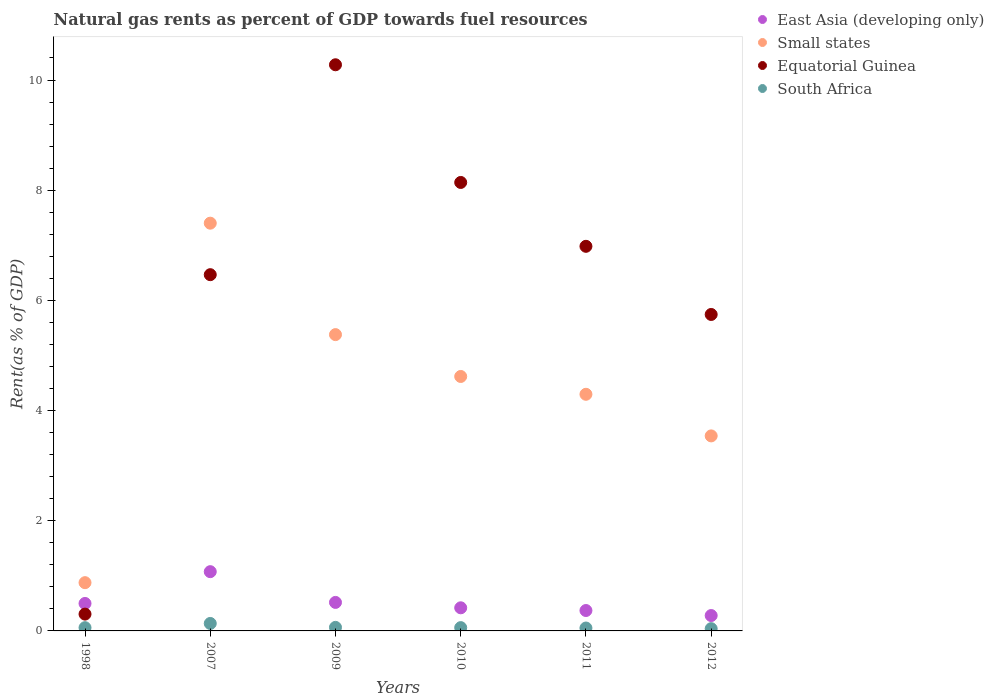Is the number of dotlines equal to the number of legend labels?
Ensure brevity in your answer.  Yes. What is the matural gas rent in Small states in 2012?
Give a very brief answer. 3.54. Across all years, what is the maximum matural gas rent in South Africa?
Give a very brief answer. 0.14. Across all years, what is the minimum matural gas rent in East Asia (developing only)?
Offer a terse response. 0.28. In which year was the matural gas rent in Equatorial Guinea maximum?
Your answer should be very brief. 2009. What is the total matural gas rent in Small states in the graph?
Provide a short and direct response. 26.11. What is the difference between the matural gas rent in Equatorial Guinea in 2009 and that in 2012?
Your answer should be very brief. 4.53. What is the difference between the matural gas rent in East Asia (developing only) in 2010 and the matural gas rent in South Africa in 2012?
Offer a very short reply. 0.38. What is the average matural gas rent in Small states per year?
Your answer should be compact. 4.35. In the year 2011, what is the difference between the matural gas rent in Small states and matural gas rent in East Asia (developing only)?
Make the answer very short. 3.93. What is the ratio of the matural gas rent in East Asia (developing only) in 2011 to that in 2012?
Keep it short and to the point. 1.33. Is the difference between the matural gas rent in Small states in 2010 and 2011 greater than the difference between the matural gas rent in East Asia (developing only) in 2010 and 2011?
Your answer should be compact. Yes. What is the difference between the highest and the second highest matural gas rent in South Africa?
Give a very brief answer. 0.07. What is the difference between the highest and the lowest matural gas rent in East Asia (developing only)?
Give a very brief answer. 0.8. In how many years, is the matural gas rent in South Africa greater than the average matural gas rent in South Africa taken over all years?
Offer a very short reply. 1. Is it the case that in every year, the sum of the matural gas rent in South Africa and matural gas rent in Small states  is greater than the sum of matural gas rent in East Asia (developing only) and matural gas rent in Equatorial Guinea?
Keep it short and to the point. Yes. Is it the case that in every year, the sum of the matural gas rent in South Africa and matural gas rent in East Asia (developing only)  is greater than the matural gas rent in Small states?
Provide a short and direct response. No. Is the matural gas rent in South Africa strictly greater than the matural gas rent in East Asia (developing only) over the years?
Your response must be concise. No. Is the matural gas rent in East Asia (developing only) strictly less than the matural gas rent in Equatorial Guinea over the years?
Your answer should be very brief. No. How many years are there in the graph?
Give a very brief answer. 6. What is the difference between two consecutive major ticks on the Y-axis?
Ensure brevity in your answer.  2. Are the values on the major ticks of Y-axis written in scientific E-notation?
Make the answer very short. No. Does the graph contain any zero values?
Your response must be concise. No. How many legend labels are there?
Offer a very short reply. 4. How are the legend labels stacked?
Your answer should be very brief. Vertical. What is the title of the graph?
Your answer should be very brief. Natural gas rents as percent of GDP towards fuel resources. Does "Pakistan" appear as one of the legend labels in the graph?
Keep it short and to the point. No. What is the label or title of the X-axis?
Give a very brief answer. Years. What is the label or title of the Y-axis?
Provide a short and direct response. Rent(as % of GDP). What is the Rent(as % of GDP) in East Asia (developing only) in 1998?
Keep it short and to the point. 0.5. What is the Rent(as % of GDP) of Small states in 1998?
Keep it short and to the point. 0.88. What is the Rent(as % of GDP) of Equatorial Guinea in 1998?
Provide a short and direct response. 0.31. What is the Rent(as % of GDP) of South Africa in 1998?
Offer a terse response. 0.06. What is the Rent(as % of GDP) of East Asia (developing only) in 2007?
Ensure brevity in your answer.  1.08. What is the Rent(as % of GDP) of Small states in 2007?
Keep it short and to the point. 7.4. What is the Rent(as % of GDP) in Equatorial Guinea in 2007?
Your answer should be very brief. 6.47. What is the Rent(as % of GDP) in South Africa in 2007?
Give a very brief answer. 0.14. What is the Rent(as % of GDP) of East Asia (developing only) in 2009?
Your answer should be compact. 0.52. What is the Rent(as % of GDP) of Small states in 2009?
Your answer should be very brief. 5.38. What is the Rent(as % of GDP) in Equatorial Guinea in 2009?
Provide a succinct answer. 10.28. What is the Rent(as % of GDP) in South Africa in 2009?
Offer a very short reply. 0.06. What is the Rent(as % of GDP) of East Asia (developing only) in 2010?
Make the answer very short. 0.42. What is the Rent(as % of GDP) in Small states in 2010?
Give a very brief answer. 4.62. What is the Rent(as % of GDP) of Equatorial Guinea in 2010?
Make the answer very short. 8.14. What is the Rent(as % of GDP) in South Africa in 2010?
Your answer should be compact. 0.06. What is the Rent(as % of GDP) of East Asia (developing only) in 2011?
Provide a succinct answer. 0.37. What is the Rent(as % of GDP) in Small states in 2011?
Offer a terse response. 4.3. What is the Rent(as % of GDP) in Equatorial Guinea in 2011?
Your answer should be compact. 6.98. What is the Rent(as % of GDP) of South Africa in 2011?
Offer a terse response. 0.05. What is the Rent(as % of GDP) in East Asia (developing only) in 2012?
Give a very brief answer. 0.28. What is the Rent(as % of GDP) in Small states in 2012?
Offer a terse response. 3.54. What is the Rent(as % of GDP) in Equatorial Guinea in 2012?
Your answer should be very brief. 5.74. What is the Rent(as % of GDP) in South Africa in 2012?
Keep it short and to the point. 0.04. Across all years, what is the maximum Rent(as % of GDP) of East Asia (developing only)?
Your answer should be very brief. 1.08. Across all years, what is the maximum Rent(as % of GDP) of Small states?
Ensure brevity in your answer.  7.4. Across all years, what is the maximum Rent(as % of GDP) of Equatorial Guinea?
Provide a short and direct response. 10.28. Across all years, what is the maximum Rent(as % of GDP) in South Africa?
Provide a succinct answer. 0.14. Across all years, what is the minimum Rent(as % of GDP) of East Asia (developing only)?
Offer a terse response. 0.28. Across all years, what is the minimum Rent(as % of GDP) of Small states?
Provide a short and direct response. 0.88. Across all years, what is the minimum Rent(as % of GDP) of Equatorial Guinea?
Offer a terse response. 0.31. Across all years, what is the minimum Rent(as % of GDP) in South Africa?
Provide a succinct answer. 0.04. What is the total Rent(as % of GDP) in East Asia (developing only) in the graph?
Make the answer very short. 3.16. What is the total Rent(as % of GDP) of Small states in the graph?
Keep it short and to the point. 26.11. What is the total Rent(as % of GDP) in Equatorial Guinea in the graph?
Give a very brief answer. 37.92. What is the total Rent(as % of GDP) of South Africa in the graph?
Your answer should be very brief. 0.41. What is the difference between the Rent(as % of GDP) in East Asia (developing only) in 1998 and that in 2007?
Provide a short and direct response. -0.58. What is the difference between the Rent(as % of GDP) in Small states in 1998 and that in 2007?
Offer a terse response. -6.53. What is the difference between the Rent(as % of GDP) in Equatorial Guinea in 1998 and that in 2007?
Give a very brief answer. -6.16. What is the difference between the Rent(as % of GDP) in South Africa in 1998 and that in 2007?
Offer a very short reply. -0.08. What is the difference between the Rent(as % of GDP) of East Asia (developing only) in 1998 and that in 2009?
Make the answer very short. -0.02. What is the difference between the Rent(as % of GDP) of Small states in 1998 and that in 2009?
Your answer should be compact. -4.5. What is the difference between the Rent(as % of GDP) of Equatorial Guinea in 1998 and that in 2009?
Make the answer very short. -9.97. What is the difference between the Rent(as % of GDP) in South Africa in 1998 and that in 2009?
Keep it short and to the point. -0.01. What is the difference between the Rent(as % of GDP) of East Asia (developing only) in 1998 and that in 2010?
Offer a terse response. 0.08. What is the difference between the Rent(as % of GDP) in Small states in 1998 and that in 2010?
Provide a succinct answer. -3.74. What is the difference between the Rent(as % of GDP) of Equatorial Guinea in 1998 and that in 2010?
Your response must be concise. -7.84. What is the difference between the Rent(as % of GDP) in South Africa in 1998 and that in 2010?
Ensure brevity in your answer.  -0. What is the difference between the Rent(as % of GDP) of East Asia (developing only) in 1998 and that in 2011?
Keep it short and to the point. 0.13. What is the difference between the Rent(as % of GDP) of Small states in 1998 and that in 2011?
Ensure brevity in your answer.  -3.42. What is the difference between the Rent(as % of GDP) in Equatorial Guinea in 1998 and that in 2011?
Ensure brevity in your answer.  -6.68. What is the difference between the Rent(as % of GDP) of South Africa in 1998 and that in 2011?
Your answer should be compact. 0.01. What is the difference between the Rent(as % of GDP) of East Asia (developing only) in 1998 and that in 2012?
Provide a short and direct response. 0.22. What is the difference between the Rent(as % of GDP) of Small states in 1998 and that in 2012?
Your answer should be compact. -2.66. What is the difference between the Rent(as % of GDP) of Equatorial Guinea in 1998 and that in 2012?
Provide a succinct answer. -5.44. What is the difference between the Rent(as % of GDP) in South Africa in 1998 and that in 2012?
Ensure brevity in your answer.  0.02. What is the difference between the Rent(as % of GDP) in East Asia (developing only) in 2007 and that in 2009?
Provide a short and direct response. 0.56. What is the difference between the Rent(as % of GDP) in Small states in 2007 and that in 2009?
Your answer should be compact. 2.02. What is the difference between the Rent(as % of GDP) of Equatorial Guinea in 2007 and that in 2009?
Give a very brief answer. -3.81. What is the difference between the Rent(as % of GDP) in South Africa in 2007 and that in 2009?
Give a very brief answer. 0.07. What is the difference between the Rent(as % of GDP) of East Asia (developing only) in 2007 and that in 2010?
Offer a terse response. 0.66. What is the difference between the Rent(as % of GDP) of Small states in 2007 and that in 2010?
Make the answer very short. 2.78. What is the difference between the Rent(as % of GDP) in Equatorial Guinea in 2007 and that in 2010?
Offer a terse response. -1.67. What is the difference between the Rent(as % of GDP) in South Africa in 2007 and that in 2010?
Provide a short and direct response. 0.08. What is the difference between the Rent(as % of GDP) of East Asia (developing only) in 2007 and that in 2011?
Your answer should be very brief. 0.71. What is the difference between the Rent(as % of GDP) in Small states in 2007 and that in 2011?
Offer a terse response. 3.11. What is the difference between the Rent(as % of GDP) of Equatorial Guinea in 2007 and that in 2011?
Give a very brief answer. -0.51. What is the difference between the Rent(as % of GDP) in South Africa in 2007 and that in 2011?
Your answer should be very brief. 0.08. What is the difference between the Rent(as % of GDP) of East Asia (developing only) in 2007 and that in 2012?
Provide a succinct answer. 0.8. What is the difference between the Rent(as % of GDP) of Small states in 2007 and that in 2012?
Your answer should be very brief. 3.86. What is the difference between the Rent(as % of GDP) of Equatorial Guinea in 2007 and that in 2012?
Your answer should be compact. 0.72. What is the difference between the Rent(as % of GDP) of South Africa in 2007 and that in 2012?
Offer a very short reply. 0.09. What is the difference between the Rent(as % of GDP) in East Asia (developing only) in 2009 and that in 2010?
Make the answer very short. 0.1. What is the difference between the Rent(as % of GDP) in Small states in 2009 and that in 2010?
Your response must be concise. 0.76. What is the difference between the Rent(as % of GDP) of Equatorial Guinea in 2009 and that in 2010?
Keep it short and to the point. 2.14. What is the difference between the Rent(as % of GDP) in South Africa in 2009 and that in 2010?
Give a very brief answer. 0. What is the difference between the Rent(as % of GDP) in East Asia (developing only) in 2009 and that in 2011?
Provide a succinct answer. 0.15. What is the difference between the Rent(as % of GDP) in Small states in 2009 and that in 2011?
Make the answer very short. 1.08. What is the difference between the Rent(as % of GDP) of Equatorial Guinea in 2009 and that in 2011?
Offer a very short reply. 3.3. What is the difference between the Rent(as % of GDP) in South Africa in 2009 and that in 2011?
Offer a terse response. 0.01. What is the difference between the Rent(as % of GDP) of East Asia (developing only) in 2009 and that in 2012?
Provide a short and direct response. 0.24. What is the difference between the Rent(as % of GDP) of Small states in 2009 and that in 2012?
Your answer should be very brief. 1.84. What is the difference between the Rent(as % of GDP) in Equatorial Guinea in 2009 and that in 2012?
Give a very brief answer. 4.53. What is the difference between the Rent(as % of GDP) in South Africa in 2009 and that in 2012?
Ensure brevity in your answer.  0.02. What is the difference between the Rent(as % of GDP) of East Asia (developing only) in 2010 and that in 2011?
Provide a succinct answer. 0.05. What is the difference between the Rent(as % of GDP) of Small states in 2010 and that in 2011?
Ensure brevity in your answer.  0.32. What is the difference between the Rent(as % of GDP) in Equatorial Guinea in 2010 and that in 2011?
Your response must be concise. 1.16. What is the difference between the Rent(as % of GDP) of South Africa in 2010 and that in 2011?
Provide a short and direct response. 0.01. What is the difference between the Rent(as % of GDP) of East Asia (developing only) in 2010 and that in 2012?
Provide a short and direct response. 0.14. What is the difference between the Rent(as % of GDP) in Small states in 2010 and that in 2012?
Give a very brief answer. 1.08. What is the difference between the Rent(as % of GDP) in Equatorial Guinea in 2010 and that in 2012?
Your response must be concise. 2.4. What is the difference between the Rent(as % of GDP) of South Africa in 2010 and that in 2012?
Ensure brevity in your answer.  0.02. What is the difference between the Rent(as % of GDP) in East Asia (developing only) in 2011 and that in 2012?
Your answer should be compact. 0.09. What is the difference between the Rent(as % of GDP) of Small states in 2011 and that in 2012?
Ensure brevity in your answer.  0.76. What is the difference between the Rent(as % of GDP) of Equatorial Guinea in 2011 and that in 2012?
Your answer should be compact. 1.24. What is the difference between the Rent(as % of GDP) in South Africa in 2011 and that in 2012?
Offer a terse response. 0.01. What is the difference between the Rent(as % of GDP) in East Asia (developing only) in 1998 and the Rent(as % of GDP) in Small states in 2007?
Your answer should be very brief. -6.9. What is the difference between the Rent(as % of GDP) in East Asia (developing only) in 1998 and the Rent(as % of GDP) in Equatorial Guinea in 2007?
Your response must be concise. -5.97. What is the difference between the Rent(as % of GDP) of East Asia (developing only) in 1998 and the Rent(as % of GDP) of South Africa in 2007?
Your answer should be very brief. 0.36. What is the difference between the Rent(as % of GDP) of Small states in 1998 and the Rent(as % of GDP) of Equatorial Guinea in 2007?
Offer a very short reply. -5.59. What is the difference between the Rent(as % of GDP) of Small states in 1998 and the Rent(as % of GDP) of South Africa in 2007?
Ensure brevity in your answer.  0.74. What is the difference between the Rent(as % of GDP) of Equatorial Guinea in 1998 and the Rent(as % of GDP) of South Africa in 2007?
Keep it short and to the point. 0.17. What is the difference between the Rent(as % of GDP) of East Asia (developing only) in 1998 and the Rent(as % of GDP) of Small states in 2009?
Offer a very short reply. -4.88. What is the difference between the Rent(as % of GDP) in East Asia (developing only) in 1998 and the Rent(as % of GDP) in Equatorial Guinea in 2009?
Provide a succinct answer. -9.78. What is the difference between the Rent(as % of GDP) in East Asia (developing only) in 1998 and the Rent(as % of GDP) in South Africa in 2009?
Keep it short and to the point. 0.43. What is the difference between the Rent(as % of GDP) of Small states in 1998 and the Rent(as % of GDP) of Equatorial Guinea in 2009?
Your response must be concise. -9.4. What is the difference between the Rent(as % of GDP) in Small states in 1998 and the Rent(as % of GDP) in South Africa in 2009?
Give a very brief answer. 0.81. What is the difference between the Rent(as % of GDP) of Equatorial Guinea in 1998 and the Rent(as % of GDP) of South Africa in 2009?
Make the answer very short. 0.24. What is the difference between the Rent(as % of GDP) of East Asia (developing only) in 1998 and the Rent(as % of GDP) of Small states in 2010?
Your response must be concise. -4.12. What is the difference between the Rent(as % of GDP) of East Asia (developing only) in 1998 and the Rent(as % of GDP) of Equatorial Guinea in 2010?
Your answer should be compact. -7.64. What is the difference between the Rent(as % of GDP) in East Asia (developing only) in 1998 and the Rent(as % of GDP) in South Africa in 2010?
Your answer should be compact. 0.44. What is the difference between the Rent(as % of GDP) in Small states in 1998 and the Rent(as % of GDP) in Equatorial Guinea in 2010?
Keep it short and to the point. -7.26. What is the difference between the Rent(as % of GDP) of Small states in 1998 and the Rent(as % of GDP) of South Africa in 2010?
Your response must be concise. 0.82. What is the difference between the Rent(as % of GDP) of Equatorial Guinea in 1998 and the Rent(as % of GDP) of South Africa in 2010?
Your answer should be compact. 0.25. What is the difference between the Rent(as % of GDP) of East Asia (developing only) in 1998 and the Rent(as % of GDP) of Small states in 2011?
Provide a short and direct response. -3.8. What is the difference between the Rent(as % of GDP) in East Asia (developing only) in 1998 and the Rent(as % of GDP) in Equatorial Guinea in 2011?
Make the answer very short. -6.48. What is the difference between the Rent(as % of GDP) of East Asia (developing only) in 1998 and the Rent(as % of GDP) of South Africa in 2011?
Give a very brief answer. 0.45. What is the difference between the Rent(as % of GDP) of Small states in 1998 and the Rent(as % of GDP) of Equatorial Guinea in 2011?
Offer a terse response. -6.11. What is the difference between the Rent(as % of GDP) of Small states in 1998 and the Rent(as % of GDP) of South Africa in 2011?
Provide a succinct answer. 0.82. What is the difference between the Rent(as % of GDP) of Equatorial Guinea in 1998 and the Rent(as % of GDP) of South Africa in 2011?
Your answer should be very brief. 0.25. What is the difference between the Rent(as % of GDP) in East Asia (developing only) in 1998 and the Rent(as % of GDP) in Small states in 2012?
Ensure brevity in your answer.  -3.04. What is the difference between the Rent(as % of GDP) of East Asia (developing only) in 1998 and the Rent(as % of GDP) of Equatorial Guinea in 2012?
Give a very brief answer. -5.25. What is the difference between the Rent(as % of GDP) in East Asia (developing only) in 1998 and the Rent(as % of GDP) in South Africa in 2012?
Your response must be concise. 0.46. What is the difference between the Rent(as % of GDP) in Small states in 1998 and the Rent(as % of GDP) in Equatorial Guinea in 2012?
Give a very brief answer. -4.87. What is the difference between the Rent(as % of GDP) in Small states in 1998 and the Rent(as % of GDP) in South Africa in 2012?
Provide a succinct answer. 0.84. What is the difference between the Rent(as % of GDP) in Equatorial Guinea in 1998 and the Rent(as % of GDP) in South Africa in 2012?
Ensure brevity in your answer.  0.26. What is the difference between the Rent(as % of GDP) in East Asia (developing only) in 2007 and the Rent(as % of GDP) in Small states in 2009?
Offer a very short reply. -4.3. What is the difference between the Rent(as % of GDP) of East Asia (developing only) in 2007 and the Rent(as % of GDP) of Equatorial Guinea in 2009?
Provide a succinct answer. -9.2. What is the difference between the Rent(as % of GDP) in East Asia (developing only) in 2007 and the Rent(as % of GDP) in South Africa in 2009?
Provide a short and direct response. 1.01. What is the difference between the Rent(as % of GDP) in Small states in 2007 and the Rent(as % of GDP) in Equatorial Guinea in 2009?
Your response must be concise. -2.88. What is the difference between the Rent(as % of GDP) of Small states in 2007 and the Rent(as % of GDP) of South Africa in 2009?
Your answer should be very brief. 7.34. What is the difference between the Rent(as % of GDP) in Equatorial Guinea in 2007 and the Rent(as % of GDP) in South Africa in 2009?
Make the answer very short. 6.4. What is the difference between the Rent(as % of GDP) of East Asia (developing only) in 2007 and the Rent(as % of GDP) of Small states in 2010?
Give a very brief answer. -3.54. What is the difference between the Rent(as % of GDP) in East Asia (developing only) in 2007 and the Rent(as % of GDP) in Equatorial Guinea in 2010?
Offer a very short reply. -7.07. What is the difference between the Rent(as % of GDP) in East Asia (developing only) in 2007 and the Rent(as % of GDP) in South Africa in 2010?
Ensure brevity in your answer.  1.02. What is the difference between the Rent(as % of GDP) of Small states in 2007 and the Rent(as % of GDP) of Equatorial Guinea in 2010?
Keep it short and to the point. -0.74. What is the difference between the Rent(as % of GDP) of Small states in 2007 and the Rent(as % of GDP) of South Africa in 2010?
Keep it short and to the point. 7.34. What is the difference between the Rent(as % of GDP) in Equatorial Guinea in 2007 and the Rent(as % of GDP) in South Africa in 2010?
Give a very brief answer. 6.41. What is the difference between the Rent(as % of GDP) in East Asia (developing only) in 2007 and the Rent(as % of GDP) in Small states in 2011?
Provide a short and direct response. -3.22. What is the difference between the Rent(as % of GDP) of East Asia (developing only) in 2007 and the Rent(as % of GDP) of Equatorial Guinea in 2011?
Offer a very short reply. -5.91. What is the difference between the Rent(as % of GDP) in East Asia (developing only) in 2007 and the Rent(as % of GDP) in South Africa in 2011?
Offer a very short reply. 1.02. What is the difference between the Rent(as % of GDP) in Small states in 2007 and the Rent(as % of GDP) in Equatorial Guinea in 2011?
Your response must be concise. 0.42. What is the difference between the Rent(as % of GDP) of Small states in 2007 and the Rent(as % of GDP) of South Africa in 2011?
Your answer should be compact. 7.35. What is the difference between the Rent(as % of GDP) of Equatorial Guinea in 2007 and the Rent(as % of GDP) of South Africa in 2011?
Provide a succinct answer. 6.41. What is the difference between the Rent(as % of GDP) of East Asia (developing only) in 2007 and the Rent(as % of GDP) of Small states in 2012?
Keep it short and to the point. -2.46. What is the difference between the Rent(as % of GDP) of East Asia (developing only) in 2007 and the Rent(as % of GDP) of Equatorial Guinea in 2012?
Offer a terse response. -4.67. What is the difference between the Rent(as % of GDP) of East Asia (developing only) in 2007 and the Rent(as % of GDP) of South Africa in 2012?
Provide a short and direct response. 1.03. What is the difference between the Rent(as % of GDP) in Small states in 2007 and the Rent(as % of GDP) in Equatorial Guinea in 2012?
Provide a succinct answer. 1.66. What is the difference between the Rent(as % of GDP) in Small states in 2007 and the Rent(as % of GDP) in South Africa in 2012?
Give a very brief answer. 7.36. What is the difference between the Rent(as % of GDP) of Equatorial Guinea in 2007 and the Rent(as % of GDP) of South Africa in 2012?
Your response must be concise. 6.43. What is the difference between the Rent(as % of GDP) in East Asia (developing only) in 2009 and the Rent(as % of GDP) in Small states in 2010?
Your answer should be very brief. -4.1. What is the difference between the Rent(as % of GDP) in East Asia (developing only) in 2009 and the Rent(as % of GDP) in Equatorial Guinea in 2010?
Make the answer very short. -7.62. What is the difference between the Rent(as % of GDP) of East Asia (developing only) in 2009 and the Rent(as % of GDP) of South Africa in 2010?
Give a very brief answer. 0.46. What is the difference between the Rent(as % of GDP) of Small states in 2009 and the Rent(as % of GDP) of Equatorial Guinea in 2010?
Give a very brief answer. -2.76. What is the difference between the Rent(as % of GDP) of Small states in 2009 and the Rent(as % of GDP) of South Africa in 2010?
Your response must be concise. 5.32. What is the difference between the Rent(as % of GDP) of Equatorial Guinea in 2009 and the Rent(as % of GDP) of South Africa in 2010?
Offer a very short reply. 10.22. What is the difference between the Rent(as % of GDP) in East Asia (developing only) in 2009 and the Rent(as % of GDP) in Small states in 2011?
Ensure brevity in your answer.  -3.78. What is the difference between the Rent(as % of GDP) of East Asia (developing only) in 2009 and the Rent(as % of GDP) of Equatorial Guinea in 2011?
Your response must be concise. -6.46. What is the difference between the Rent(as % of GDP) in East Asia (developing only) in 2009 and the Rent(as % of GDP) in South Africa in 2011?
Keep it short and to the point. 0.47. What is the difference between the Rent(as % of GDP) of Small states in 2009 and the Rent(as % of GDP) of Equatorial Guinea in 2011?
Provide a short and direct response. -1.6. What is the difference between the Rent(as % of GDP) in Small states in 2009 and the Rent(as % of GDP) in South Africa in 2011?
Your answer should be compact. 5.33. What is the difference between the Rent(as % of GDP) in Equatorial Guinea in 2009 and the Rent(as % of GDP) in South Africa in 2011?
Your answer should be compact. 10.22. What is the difference between the Rent(as % of GDP) of East Asia (developing only) in 2009 and the Rent(as % of GDP) of Small states in 2012?
Your answer should be compact. -3.02. What is the difference between the Rent(as % of GDP) in East Asia (developing only) in 2009 and the Rent(as % of GDP) in Equatorial Guinea in 2012?
Your response must be concise. -5.23. What is the difference between the Rent(as % of GDP) of East Asia (developing only) in 2009 and the Rent(as % of GDP) of South Africa in 2012?
Ensure brevity in your answer.  0.48. What is the difference between the Rent(as % of GDP) in Small states in 2009 and the Rent(as % of GDP) in Equatorial Guinea in 2012?
Your answer should be compact. -0.37. What is the difference between the Rent(as % of GDP) in Small states in 2009 and the Rent(as % of GDP) in South Africa in 2012?
Provide a succinct answer. 5.34. What is the difference between the Rent(as % of GDP) of Equatorial Guinea in 2009 and the Rent(as % of GDP) of South Africa in 2012?
Provide a short and direct response. 10.24. What is the difference between the Rent(as % of GDP) of East Asia (developing only) in 2010 and the Rent(as % of GDP) of Small states in 2011?
Ensure brevity in your answer.  -3.88. What is the difference between the Rent(as % of GDP) of East Asia (developing only) in 2010 and the Rent(as % of GDP) of Equatorial Guinea in 2011?
Ensure brevity in your answer.  -6.56. What is the difference between the Rent(as % of GDP) in East Asia (developing only) in 2010 and the Rent(as % of GDP) in South Africa in 2011?
Give a very brief answer. 0.37. What is the difference between the Rent(as % of GDP) of Small states in 2010 and the Rent(as % of GDP) of Equatorial Guinea in 2011?
Make the answer very short. -2.36. What is the difference between the Rent(as % of GDP) of Small states in 2010 and the Rent(as % of GDP) of South Africa in 2011?
Provide a short and direct response. 4.57. What is the difference between the Rent(as % of GDP) in Equatorial Guinea in 2010 and the Rent(as % of GDP) in South Africa in 2011?
Offer a very short reply. 8.09. What is the difference between the Rent(as % of GDP) in East Asia (developing only) in 2010 and the Rent(as % of GDP) in Small states in 2012?
Provide a short and direct response. -3.12. What is the difference between the Rent(as % of GDP) in East Asia (developing only) in 2010 and the Rent(as % of GDP) in Equatorial Guinea in 2012?
Give a very brief answer. -5.32. What is the difference between the Rent(as % of GDP) in East Asia (developing only) in 2010 and the Rent(as % of GDP) in South Africa in 2012?
Ensure brevity in your answer.  0.38. What is the difference between the Rent(as % of GDP) in Small states in 2010 and the Rent(as % of GDP) in Equatorial Guinea in 2012?
Provide a short and direct response. -1.13. What is the difference between the Rent(as % of GDP) of Small states in 2010 and the Rent(as % of GDP) of South Africa in 2012?
Your answer should be very brief. 4.58. What is the difference between the Rent(as % of GDP) in Equatorial Guinea in 2010 and the Rent(as % of GDP) in South Africa in 2012?
Keep it short and to the point. 8.1. What is the difference between the Rent(as % of GDP) of East Asia (developing only) in 2011 and the Rent(as % of GDP) of Small states in 2012?
Provide a succinct answer. -3.17. What is the difference between the Rent(as % of GDP) in East Asia (developing only) in 2011 and the Rent(as % of GDP) in Equatorial Guinea in 2012?
Ensure brevity in your answer.  -5.37. What is the difference between the Rent(as % of GDP) in East Asia (developing only) in 2011 and the Rent(as % of GDP) in South Africa in 2012?
Keep it short and to the point. 0.33. What is the difference between the Rent(as % of GDP) in Small states in 2011 and the Rent(as % of GDP) in Equatorial Guinea in 2012?
Your answer should be very brief. -1.45. What is the difference between the Rent(as % of GDP) of Small states in 2011 and the Rent(as % of GDP) of South Africa in 2012?
Ensure brevity in your answer.  4.25. What is the difference between the Rent(as % of GDP) in Equatorial Guinea in 2011 and the Rent(as % of GDP) in South Africa in 2012?
Provide a short and direct response. 6.94. What is the average Rent(as % of GDP) of East Asia (developing only) per year?
Provide a short and direct response. 0.53. What is the average Rent(as % of GDP) of Small states per year?
Provide a succinct answer. 4.35. What is the average Rent(as % of GDP) in Equatorial Guinea per year?
Provide a succinct answer. 6.32. What is the average Rent(as % of GDP) of South Africa per year?
Keep it short and to the point. 0.07. In the year 1998, what is the difference between the Rent(as % of GDP) of East Asia (developing only) and Rent(as % of GDP) of Small states?
Your response must be concise. -0.38. In the year 1998, what is the difference between the Rent(as % of GDP) of East Asia (developing only) and Rent(as % of GDP) of Equatorial Guinea?
Offer a very short reply. 0.19. In the year 1998, what is the difference between the Rent(as % of GDP) of East Asia (developing only) and Rent(as % of GDP) of South Africa?
Make the answer very short. 0.44. In the year 1998, what is the difference between the Rent(as % of GDP) of Small states and Rent(as % of GDP) of Equatorial Guinea?
Provide a succinct answer. 0.57. In the year 1998, what is the difference between the Rent(as % of GDP) in Small states and Rent(as % of GDP) in South Africa?
Your answer should be very brief. 0.82. In the year 1998, what is the difference between the Rent(as % of GDP) of Equatorial Guinea and Rent(as % of GDP) of South Africa?
Give a very brief answer. 0.25. In the year 2007, what is the difference between the Rent(as % of GDP) of East Asia (developing only) and Rent(as % of GDP) of Small states?
Your response must be concise. -6.33. In the year 2007, what is the difference between the Rent(as % of GDP) in East Asia (developing only) and Rent(as % of GDP) in Equatorial Guinea?
Ensure brevity in your answer.  -5.39. In the year 2007, what is the difference between the Rent(as % of GDP) of East Asia (developing only) and Rent(as % of GDP) of South Africa?
Keep it short and to the point. 0.94. In the year 2007, what is the difference between the Rent(as % of GDP) in Small states and Rent(as % of GDP) in Equatorial Guinea?
Offer a very short reply. 0.93. In the year 2007, what is the difference between the Rent(as % of GDP) of Small states and Rent(as % of GDP) of South Africa?
Offer a very short reply. 7.27. In the year 2007, what is the difference between the Rent(as % of GDP) in Equatorial Guinea and Rent(as % of GDP) in South Africa?
Provide a succinct answer. 6.33. In the year 2009, what is the difference between the Rent(as % of GDP) of East Asia (developing only) and Rent(as % of GDP) of Small states?
Give a very brief answer. -4.86. In the year 2009, what is the difference between the Rent(as % of GDP) of East Asia (developing only) and Rent(as % of GDP) of Equatorial Guinea?
Provide a succinct answer. -9.76. In the year 2009, what is the difference between the Rent(as % of GDP) of East Asia (developing only) and Rent(as % of GDP) of South Africa?
Your answer should be very brief. 0.45. In the year 2009, what is the difference between the Rent(as % of GDP) of Small states and Rent(as % of GDP) of Equatorial Guinea?
Offer a terse response. -4.9. In the year 2009, what is the difference between the Rent(as % of GDP) in Small states and Rent(as % of GDP) in South Africa?
Give a very brief answer. 5.31. In the year 2009, what is the difference between the Rent(as % of GDP) of Equatorial Guinea and Rent(as % of GDP) of South Africa?
Ensure brevity in your answer.  10.21. In the year 2010, what is the difference between the Rent(as % of GDP) of East Asia (developing only) and Rent(as % of GDP) of Small states?
Offer a terse response. -4.2. In the year 2010, what is the difference between the Rent(as % of GDP) of East Asia (developing only) and Rent(as % of GDP) of Equatorial Guinea?
Keep it short and to the point. -7.72. In the year 2010, what is the difference between the Rent(as % of GDP) in East Asia (developing only) and Rent(as % of GDP) in South Africa?
Provide a succinct answer. 0.36. In the year 2010, what is the difference between the Rent(as % of GDP) of Small states and Rent(as % of GDP) of Equatorial Guinea?
Your answer should be compact. -3.52. In the year 2010, what is the difference between the Rent(as % of GDP) of Small states and Rent(as % of GDP) of South Africa?
Offer a very short reply. 4.56. In the year 2010, what is the difference between the Rent(as % of GDP) in Equatorial Guinea and Rent(as % of GDP) in South Africa?
Your response must be concise. 8.08. In the year 2011, what is the difference between the Rent(as % of GDP) in East Asia (developing only) and Rent(as % of GDP) in Small states?
Your response must be concise. -3.93. In the year 2011, what is the difference between the Rent(as % of GDP) in East Asia (developing only) and Rent(as % of GDP) in Equatorial Guinea?
Keep it short and to the point. -6.61. In the year 2011, what is the difference between the Rent(as % of GDP) in East Asia (developing only) and Rent(as % of GDP) in South Africa?
Your answer should be very brief. 0.32. In the year 2011, what is the difference between the Rent(as % of GDP) of Small states and Rent(as % of GDP) of Equatorial Guinea?
Your response must be concise. -2.69. In the year 2011, what is the difference between the Rent(as % of GDP) of Small states and Rent(as % of GDP) of South Africa?
Ensure brevity in your answer.  4.24. In the year 2011, what is the difference between the Rent(as % of GDP) in Equatorial Guinea and Rent(as % of GDP) in South Africa?
Keep it short and to the point. 6.93. In the year 2012, what is the difference between the Rent(as % of GDP) in East Asia (developing only) and Rent(as % of GDP) in Small states?
Keep it short and to the point. -3.26. In the year 2012, what is the difference between the Rent(as % of GDP) of East Asia (developing only) and Rent(as % of GDP) of Equatorial Guinea?
Provide a succinct answer. -5.47. In the year 2012, what is the difference between the Rent(as % of GDP) in East Asia (developing only) and Rent(as % of GDP) in South Africa?
Offer a terse response. 0.24. In the year 2012, what is the difference between the Rent(as % of GDP) in Small states and Rent(as % of GDP) in Equatorial Guinea?
Offer a terse response. -2.2. In the year 2012, what is the difference between the Rent(as % of GDP) in Small states and Rent(as % of GDP) in South Africa?
Your answer should be very brief. 3.5. In the year 2012, what is the difference between the Rent(as % of GDP) in Equatorial Guinea and Rent(as % of GDP) in South Africa?
Your answer should be very brief. 5.7. What is the ratio of the Rent(as % of GDP) in East Asia (developing only) in 1998 to that in 2007?
Give a very brief answer. 0.46. What is the ratio of the Rent(as % of GDP) in Small states in 1998 to that in 2007?
Ensure brevity in your answer.  0.12. What is the ratio of the Rent(as % of GDP) of Equatorial Guinea in 1998 to that in 2007?
Keep it short and to the point. 0.05. What is the ratio of the Rent(as % of GDP) in South Africa in 1998 to that in 2007?
Keep it short and to the point. 0.43. What is the ratio of the Rent(as % of GDP) of East Asia (developing only) in 1998 to that in 2009?
Offer a terse response. 0.96. What is the ratio of the Rent(as % of GDP) of Small states in 1998 to that in 2009?
Your response must be concise. 0.16. What is the ratio of the Rent(as % of GDP) of Equatorial Guinea in 1998 to that in 2009?
Provide a short and direct response. 0.03. What is the ratio of the Rent(as % of GDP) of South Africa in 1998 to that in 2009?
Offer a very short reply. 0.91. What is the ratio of the Rent(as % of GDP) in East Asia (developing only) in 1998 to that in 2010?
Keep it short and to the point. 1.19. What is the ratio of the Rent(as % of GDP) of Small states in 1998 to that in 2010?
Offer a very short reply. 0.19. What is the ratio of the Rent(as % of GDP) of Equatorial Guinea in 1998 to that in 2010?
Offer a terse response. 0.04. What is the ratio of the Rent(as % of GDP) of South Africa in 1998 to that in 2010?
Keep it short and to the point. 0.99. What is the ratio of the Rent(as % of GDP) in East Asia (developing only) in 1998 to that in 2011?
Offer a terse response. 1.35. What is the ratio of the Rent(as % of GDP) of Small states in 1998 to that in 2011?
Keep it short and to the point. 0.2. What is the ratio of the Rent(as % of GDP) in Equatorial Guinea in 1998 to that in 2011?
Offer a terse response. 0.04. What is the ratio of the Rent(as % of GDP) in South Africa in 1998 to that in 2011?
Provide a succinct answer. 1.12. What is the ratio of the Rent(as % of GDP) in East Asia (developing only) in 1998 to that in 2012?
Your response must be concise. 1.79. What is the ratio of the Rent(as % of GDP) of Small states in 1998 to that in 2012?
Your response must be concise. 0.25. What is the ratio of the Rent(as % of GDP) of Equatorial Guinea in 1998 to that in 2012?
Keep it short and to the point. 0.05. What is the ratio of the Rent(as % of GDP) of South Africa in 1998 to that in 2012?
Keep it short and to the point. 1.44. What is the ratio of the Rent(as % of GDP) in East Asia (developing only) in 2007 to that in 2009?
Your answer should be compact. 2.08. What is the ratio of the Rent(as % of GDP) of Small states in 2007 to that in 2009?
Give a very brief answer. 1.38. What is the ratio of the Rent(as % of GDP) in Equatorial Guinea in 2007 to that in 2009?
Your response must be concise. 0.63. What is the ratio of the Rent(as % of GDP) of South Africa in 2007 to that in 2009?
Offer a very short reply. 2.1. What is the ratio of the Rent(as % of GDP) in East Asia (developing only) in 2007 to that in 2010?
Make the answer very short. 2.56. What is the ratio of the Rent(as % of GDP) of Small states in 2007 to that in 2010?
Keep it short and to the point. 1.6. What is the ratio of the Rent(as % of GDP) of Equatorial Guinea in 2007 to that in 2010?
Offer a terse response. 0.79. What is the ratio of the Rent(as % of GDP) in South Africa in 2007 to that in 2010?
Provide a short and direct response. 2.27. What is the ratio of the Rent(as % of GDP) of East Asia (developing only) in 2007 to that in 2011?
Offer a very short reply. 2.9. What is the ratio of the Rent(as % of GDP) in Small states in 2007 to that in 2011?
Provide a short and direct response. 1.72. What is the ratio of the Rent(as % of GDP) in Equatorial Guinea in 2007 to that in 2011?
Your answer should be very brief. 0.93. What is the ratio of the Rent(as % of GDP) of South Africa in 2007 to that in 2011?
Give a very brief answer. 2.58. What is the ratio of the Rent(as % of GDP) in East Asia (developing only) in 2007 to that in 2012?
Your answer should be compact. 3.85. What is the ratio of the Rent(as % of GDP) of Small states in 2007 to that in 2012?
Keep it short and to the point. 2.09. What is the ratio of the Rent(as % of GDP) in Equatorial Guinea in 2007 to that in 2012?
Offer a terse response. 1.13. What is the ratio of the Rent(as % of GDP) in South Africa in 2007 to that in 2012?
Your response must be concise. 3.32. What is the ratio of the Rent(as % of GDP) of East Asia (developing only) in 2009 to that in 2010?
Give a very brief answer. 1.23. What is the ratio of the Rent(as % of GDP) in Small states in 2009 to that in 2010?
Your response must be concise. 1.16. What is the ratio of the Rent(as % of GDP) of Equatorial Guinea in 2009 to that in 2010?
Offer a terse response. 1.26. What is the ratio of the Rent(as % of GDP) of South Africa in 2009 to that in 2010?
Provide a succinct answer. 1.08. What is the ratio of the Rent(as % of GDP) of East Asia (developing only) in 2009 to that in 2011?
Keep it short and to the point. 1.4. What is the ratio of the Rent(as % of GDP) of Small states in 2009 to that in 2011?
Your response must be concise. 1.25. What is the ratio of the Rent(as % of GDP) of Equatorial Guinea in 2009 to that in 2011?
Offer a terse response. 1.47. What is the ratio of the Rent(as % of GDP) of South Africa in 2009 to that in 2011?
Make the answer very short. 1.23. What is the ratio of the Rent(as % of GDP) in East Asia (developing only) in 2009 to that in 2012?
Your response must be concise. 1.85. What is the ratio of the Rent(as % of GDP) of Small states in 2009 to that in 2012?
Give a very brief answer. 1.52. What is the ratio of the Rent(as % of GDP) of Equatorial Guinea in 2009 to that in 2012?
Offer a terse response. 1.79. What is the ratio of the Rent(as % of GDP) in South Africa in 2009 to that in 2012?
Keep it short and to the point. 1.58. What is the ratio of the Rent(as % of GDP) in East Asia (developing only) in 2010 to that in 2011?
Offer a terse response. 1.13. What is the ratio of the Rent(as % of GDP) of Small states in 2010 to that in 2011?
Give a very brief answer. 1.08. What is the ratio of the Rent(as % of GDP) of Equatorial Guinea in 2010 to that in 2011?
Provide a short and direct response. 1.17. What is the ratio of the Rent(as % of GDP) in South Africa in 2010 to that in 2011?
Provide a short and direct response. 1.14. What is the ratio of the Rent(as % of GDP) in East Asia (developing only) in 2010 to that in 2012?
Ensure brevity in your answer.  1.5. What is the ratio of the Rent(as % of GDP) in Small states in 2010 to that in 2012?
Provide a short and direct response. 1.3. What is the ratio of the Rent(as % of GDP) of Equatorial Guinea in 2010 to that in 2012?
Your response must be concise. 1.42. What is the ratio of the Rent(as % of GDP) of South Africa in 2010 to that in 2012?
Ensure brevity in your answer.  1.46. What is the ratio of the Rent(as % of GDP) of East Asia (developing only) in 2011 to that in 2012?
Provide a short and direct response. 1.33. What is the ratio of the Rent(as % of GDP) of Small states in 2011 to that in 2012?
Ensure brevity in your answer.  1.21. What is the ratio of the Rent(as % of GDP) of Equatorial Guinea in 2011 to that in 2012?
Your answer should be compact. 1.22. What is the difference between the highest and the second highest Rent(as % of GDP) of East Asia (developing only)?
Make the answer very short. 0.56. What is the difference between the highest and the second highest Rent(as % of GDP) in Small states?
Give a very brief answer. 2.02. What is the difference between the highest and the second highest Rent(as % of GDP) in Equatorial Guinea?
Provide a succinct answer. 2.14. What is the difference between the highest and the second highest Rent(as % of GDP) of South Africa?
Offer a terse response. 0.07. What is the difference between the highest and the lowest Rent(as % of GDP) in East Asia (developing only)?
Ensure brevity in your answer.  0.8. What is the difference between the highest and the lowest Rent(as % of GDP) of Small states?
Provide a succinct answer. 6.53. What is the difference between the highest and the lowest Rent(as % of GDP) in Equatorial Guinea?
Your response must be concise. 9.97. What is the difference between the highest and the lowest Rent(as % of GDP) of South Africa?
Ensure brevity in your answer.  0.09. 